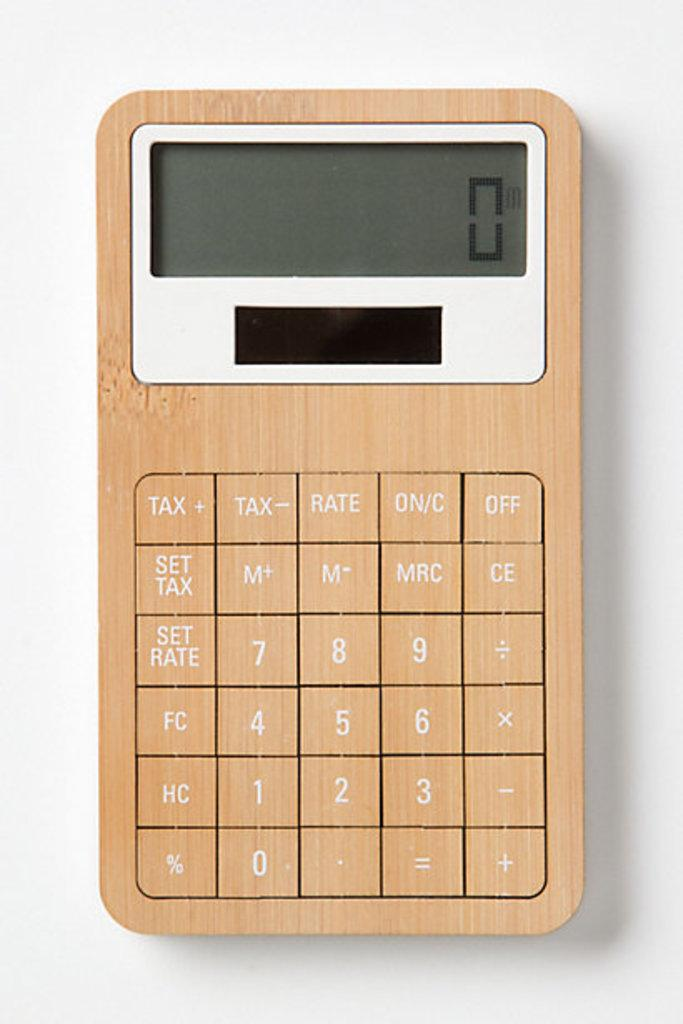<image>
Give a short and clear explanation of the subsequent image. A financial calculator which shows a 0 in the screen. 